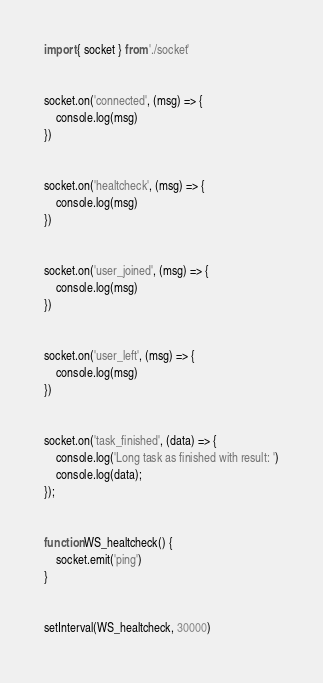<code> <loc_0><loc_0><loc_500><loc_500><_JavaScript_>import { socket } from './socket'


socket.on('connected', (msg) => {
    console.log(msg)
})


socket.on('healtcheck', (msg) => {
    console.log(msg)
})


socket.on('user_joined', (msg) => {
    console.log(msg)
})


socket.on('user_left', (msg) => {
    console.log(msg)
})


socket.on('task_finished', (data) => {
    console.log('Long task as finished with result: ')
    console.log(data);
});


function WS_healtcheck() {
    socket.emit('ping')
}


setInterval(WS_healtcheck, 30000)</code> 